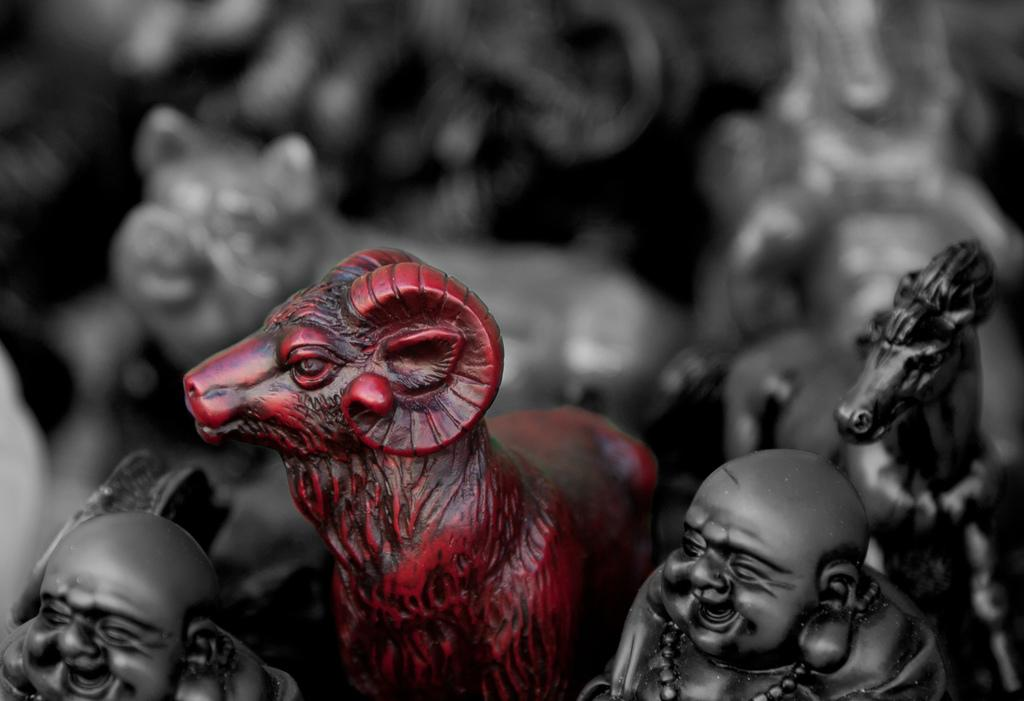What objects can be seen in the image? There are toys in the image. Can you describe the background of the image? The background of the image is blurred. Can you hear the owl in the image? There is no owl present in the image, so it is not possible to hear one. 